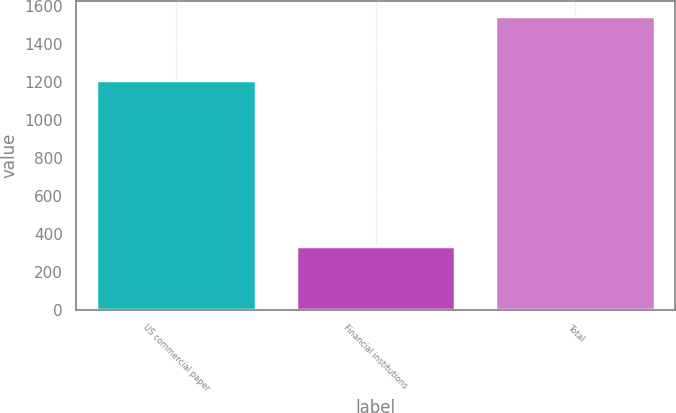<chart> <loc_0><loc_0><loc_500><loc_500><bar_chart><fcel>US commercial paper<fcel>Financial institutions<fcel>Total<nl><fcel>1213.5<fcel>336.3<fcel>1549.8<nl></chart> 